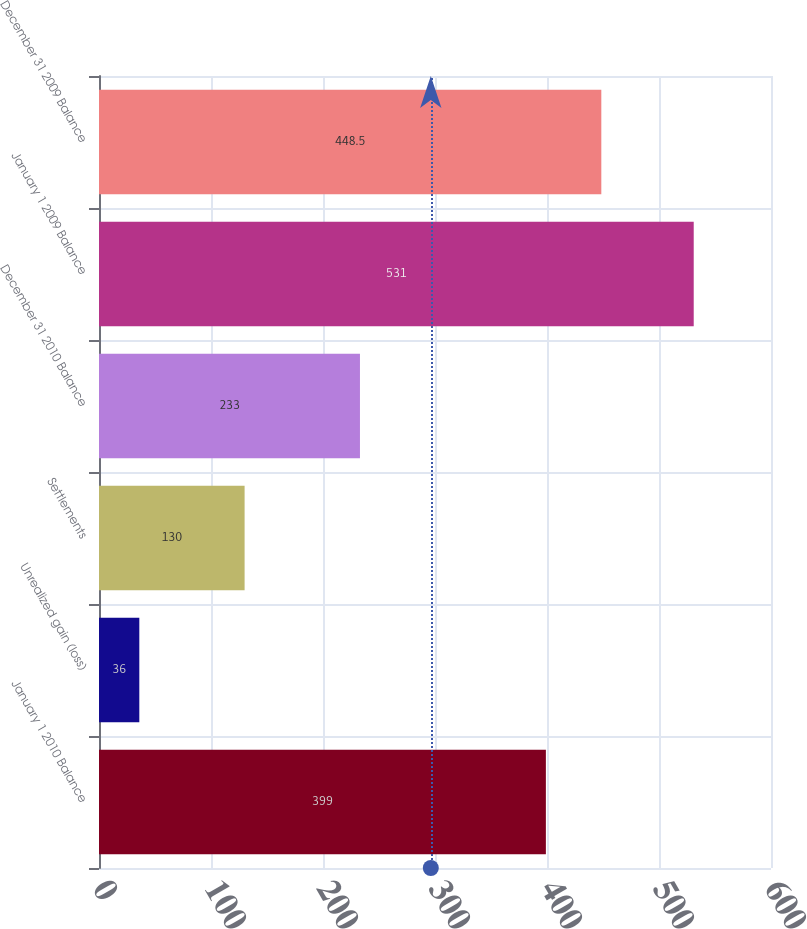Convert chart. <chart><loc_0><loc_0><loc_500><loc_500><bar_chart><fcel>January 1 2010 Balance<fcel>Unrealized gain (loss)<fcel>Settlements<fcel>December 31 2010 Balance<fcel>January 1 2009 Balance<fcel>December 31 2009 Balance<nl><fcel>399<fcel>36<fcel>130<fcel>233<fcel>531<fcel>448.5<nl></chart> 